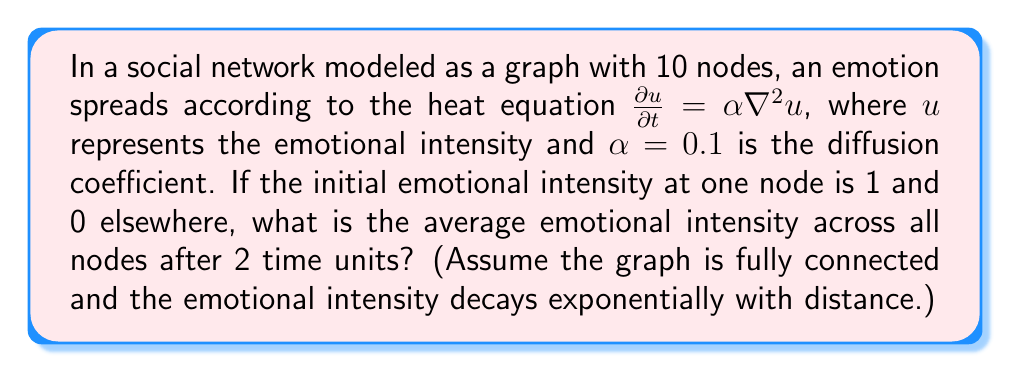Can you answer this question? To solve this problem, we'll follow these steps:

1) In a fully connected graph with 10 nodes, each node is connected to 9 others.

2) The heat equation solution for a point source in an infinite domain is:

   $$u(r,t) = \frac{1}{(4\pi\alpha t)^{n/2}} e^{-r^2/(4\alpha t)}$$

   where $n$ is the dimension (in this case, $n=1$ as we're considering linear connections), $r$ is the distance from the source, $t$ is time, and $\alpha$ is the diffusion coefficient.

3) In our graph, we can consider the distances as:
   - 1 node at distance 0 (the source)
   - 9 nodes at distance 1

4) Plugging in our values ($\alpha = 0.1$, $t = 2$):

   For the source node (r = 0):
   $$u(0,2) = \frac{1}{\sqrt{4\pi(0.1)(2)}} = \frac{1}{\sqrt{0.8\pi}} \approx 0.6267$$

   For the other 9 nodes (r = 1):
   $$u(1,2) = \frac{1}{\sqrt{4\pi(0.1)(2)}} e^{-1^2/(4(0.1)(2))} = \frac{1}{\sqrt{0.8\pi}} e^{-1.25} \approx 0.1789$$

5) The average intensity is the sum of all intensities divided by the number of nodes:

   $$\text{Average} = \frac{0.6267 + 9(0.1789)}{10} = \frac{0.6267 + 1.6101}{10} = 0.2237$$
Answer: 0.2237 